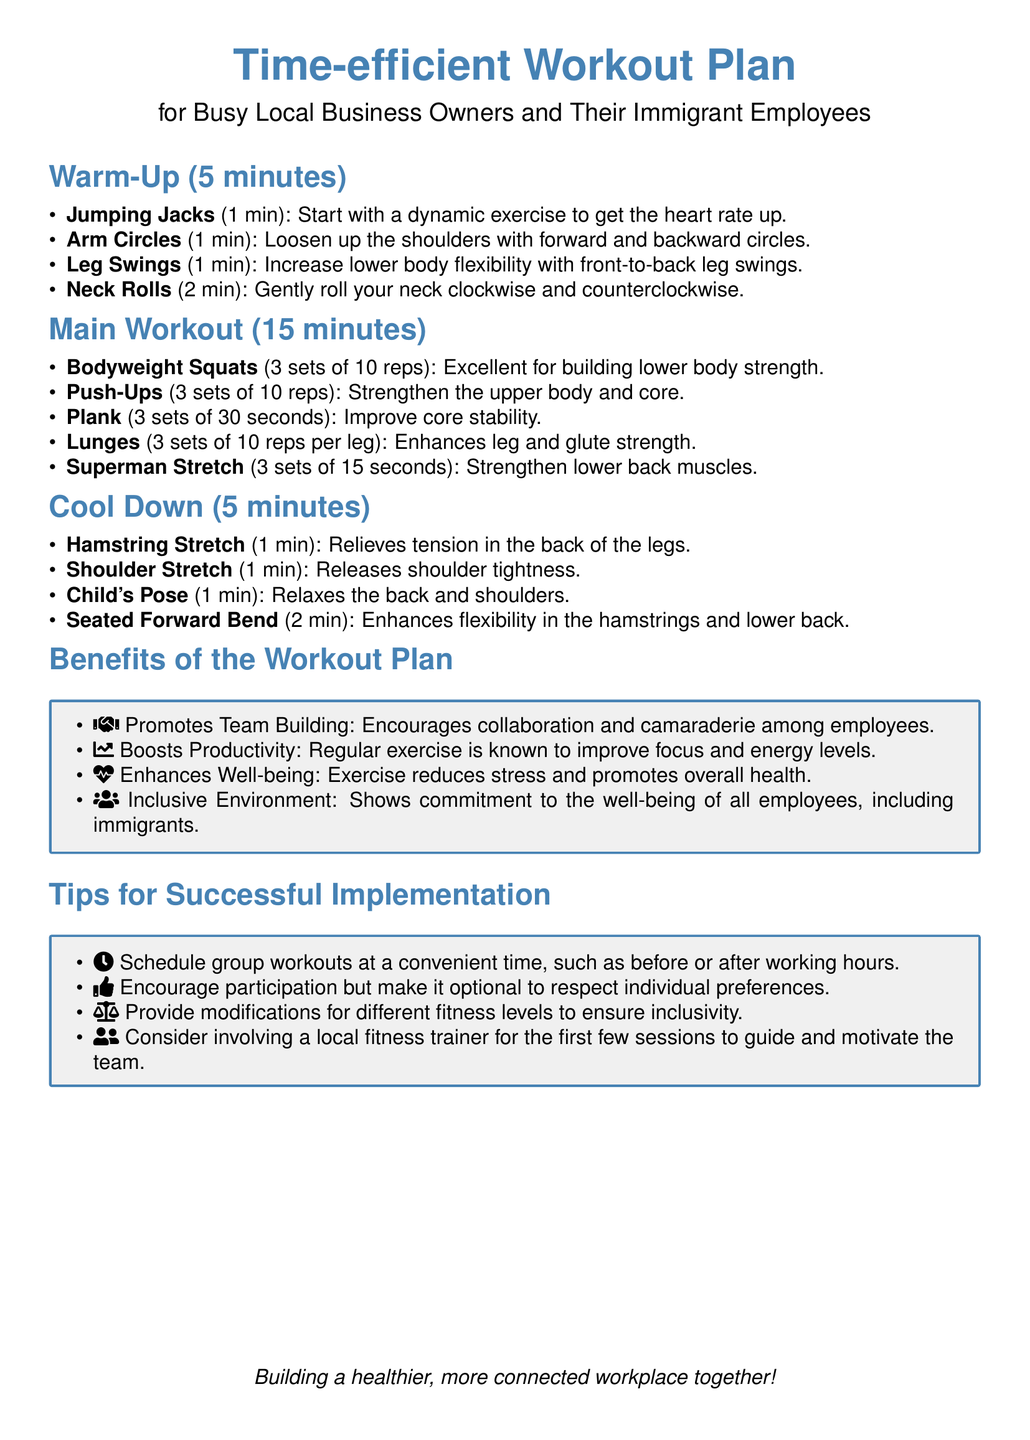What is the duration of the warm-up? The warm-up lasts for 5 minutes as stated in the document.
Answer: 5 minutes How many minutes is the main workout section? The main workout section is specified to be 15 minutes long in the document.
Answer: 15 minutes What exercise is suggested for improving core stability? The Plank is specifically mentioned for improving core stability in the workout plan.
Answer: Plank What is one benefit of the workout plan listed in the document? The document lists several benefits, one of which is enhanced well-being from exercise.
Answer: Enhances Well-being How many sets of bodyweight squats are recommended? The document states that 3 sets of 10 reps of bodyweight squats should be performed.
Answer: 3 sets of 10 reps What should group workouts be scheduled around according to the tips? The tips suggest that group workouts should be scheduled at convenient times, such as before or after working hours.
Answer: Before or after working hours What is one tip provided for ensuring inclusivity in the workout sessions? The document mentions providing modifications for different fitness levels as a tip for inclusivity.
Answer: Provide modifications What is recommended for the first few sessions to motivate the team? The recommendation is to consider involving a local fitness trainer to guide and motivate the team.
Answer: Local fitness trainer 